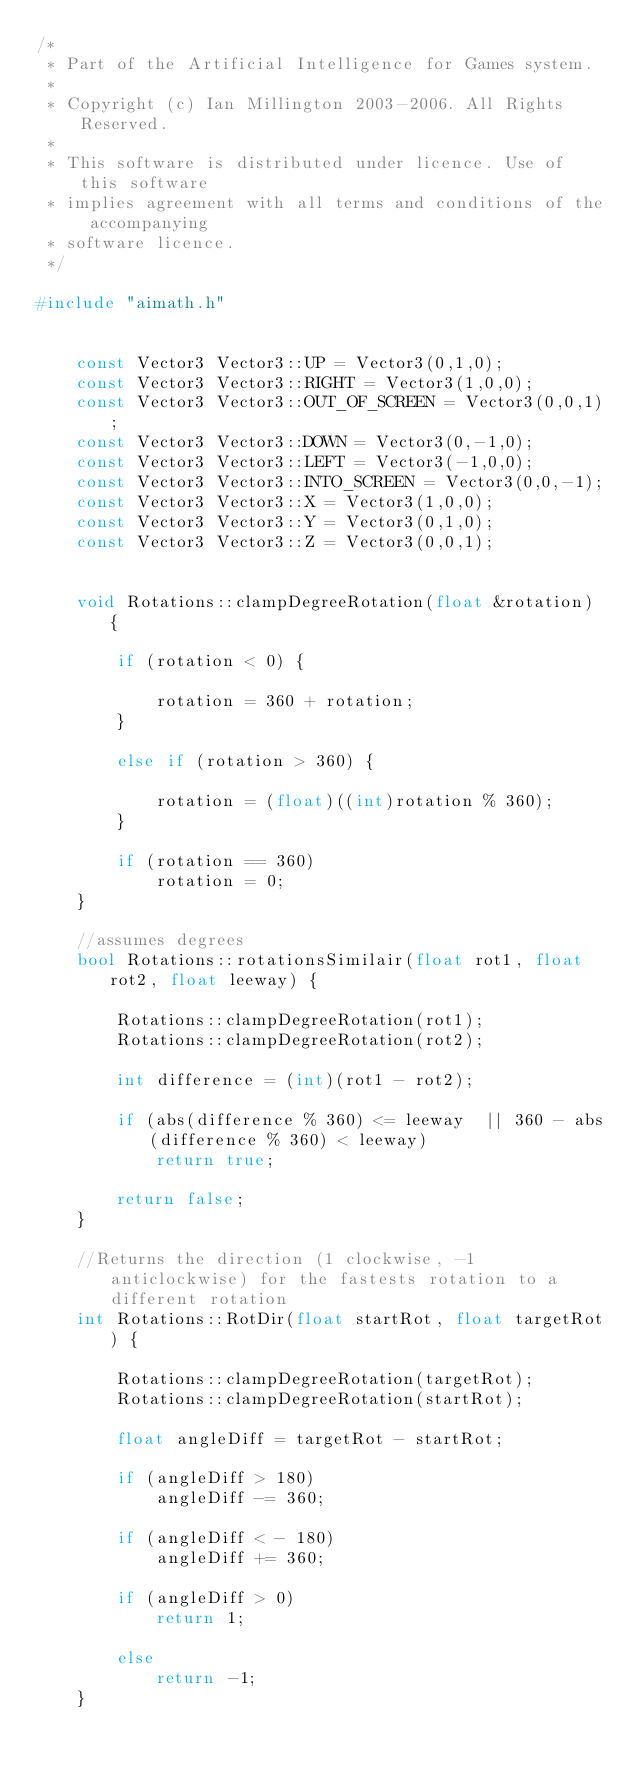<code> <loc_0><loc_0><loc_500><loc_500><_C++_>/*
 * Part of the Artificial Intelligence for Games system.
 *
 * Copyright (c) Ian Millington 2003-2006. All Rights Reserved.
 *
 * This software is distributed under licence. Use of this software
 * implies agreement with all terms and conditions of the accompanying
 * software licence.
 */

#include "aimath.h"


    const Vector3 Vector3::UP = Vector3(0,1,0);
    const Vector3 Vector3::RIGHT = Vector3(1,0,0);
    const Vector3 Vector3::OUT_OF_SCREEN = Vector3(0,0,1);
    const Vector3 Vector3::DOWN = Vector3(0,-1,0);
    const Vector3 Vector3::LEFT = Vector3(-1,0,0);
    const Vector3 Vector3::INTO_SCREEN = Vector3(0,0,-1);
    const Vector3 Vector3::X = Vector3(1,0,0);
    const Vector3 Vector3::Y = Vector3(0,1,0);
    const Vector3 Vector3::Z = Vector3(0,0,1);


	void Rotations::clampDegreeRotation(float &rotation) {

		if (rotation < 0) {

			rotation = 360 + rotation;
		}

		else if (rotation > 360) {

			rotation = (float)((int)rotation % 360);
		}

		if (rotation == 360)
			rotation = 0;
	}

	//assumes degrees
	bool Rotations::rotationsSimilair(float rot1, float rot2, float leeway) {

		Rotations::clampDegreeRotation(rot1);
		Rotations::clampDegreeRotation(rot2);

		int difference = (int)(rot1 - rot2);

		if (abs(difference % 360) <= leeway  || 360 - abs(difference % 360) < leeway)
			return true;

		return false;
	}

	//Returns the direction (1 clockwise, -1 anticlockwise) for the fastests rotation to a different rotation
	int Rotations::RotDir(float startRot, float targetRot) {

		Rotations::clampDegreeRotation(targetRot);
		Rotations::clampDegreeRotation(startRot);

		float angleDiff = targetRot - startRot;

		if (angleDiff > 180)
			angleDiff -= 360;

		if (angleDiff < - 180)
			angleDiff += 360;

		if (angleDiff > 0)
			return 1;

		else
			return -1;
	}</code> 